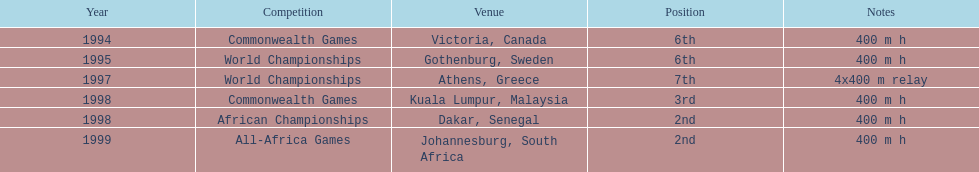What is the ultimate competition on the diagram? All-Africa Games. 